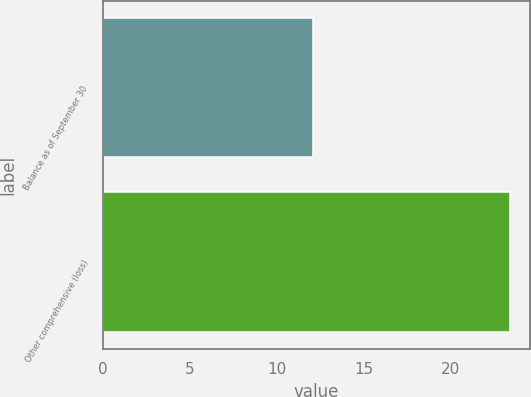Convert chart to OTSL. <chart><loc_0><loc_0><loc_500><loc_500><bar_chart><fcel>Balance as of September 30<fcel>Other comprehensive (loss)<nl><fcel>12.1<fcel>23.4<nl></chart> 